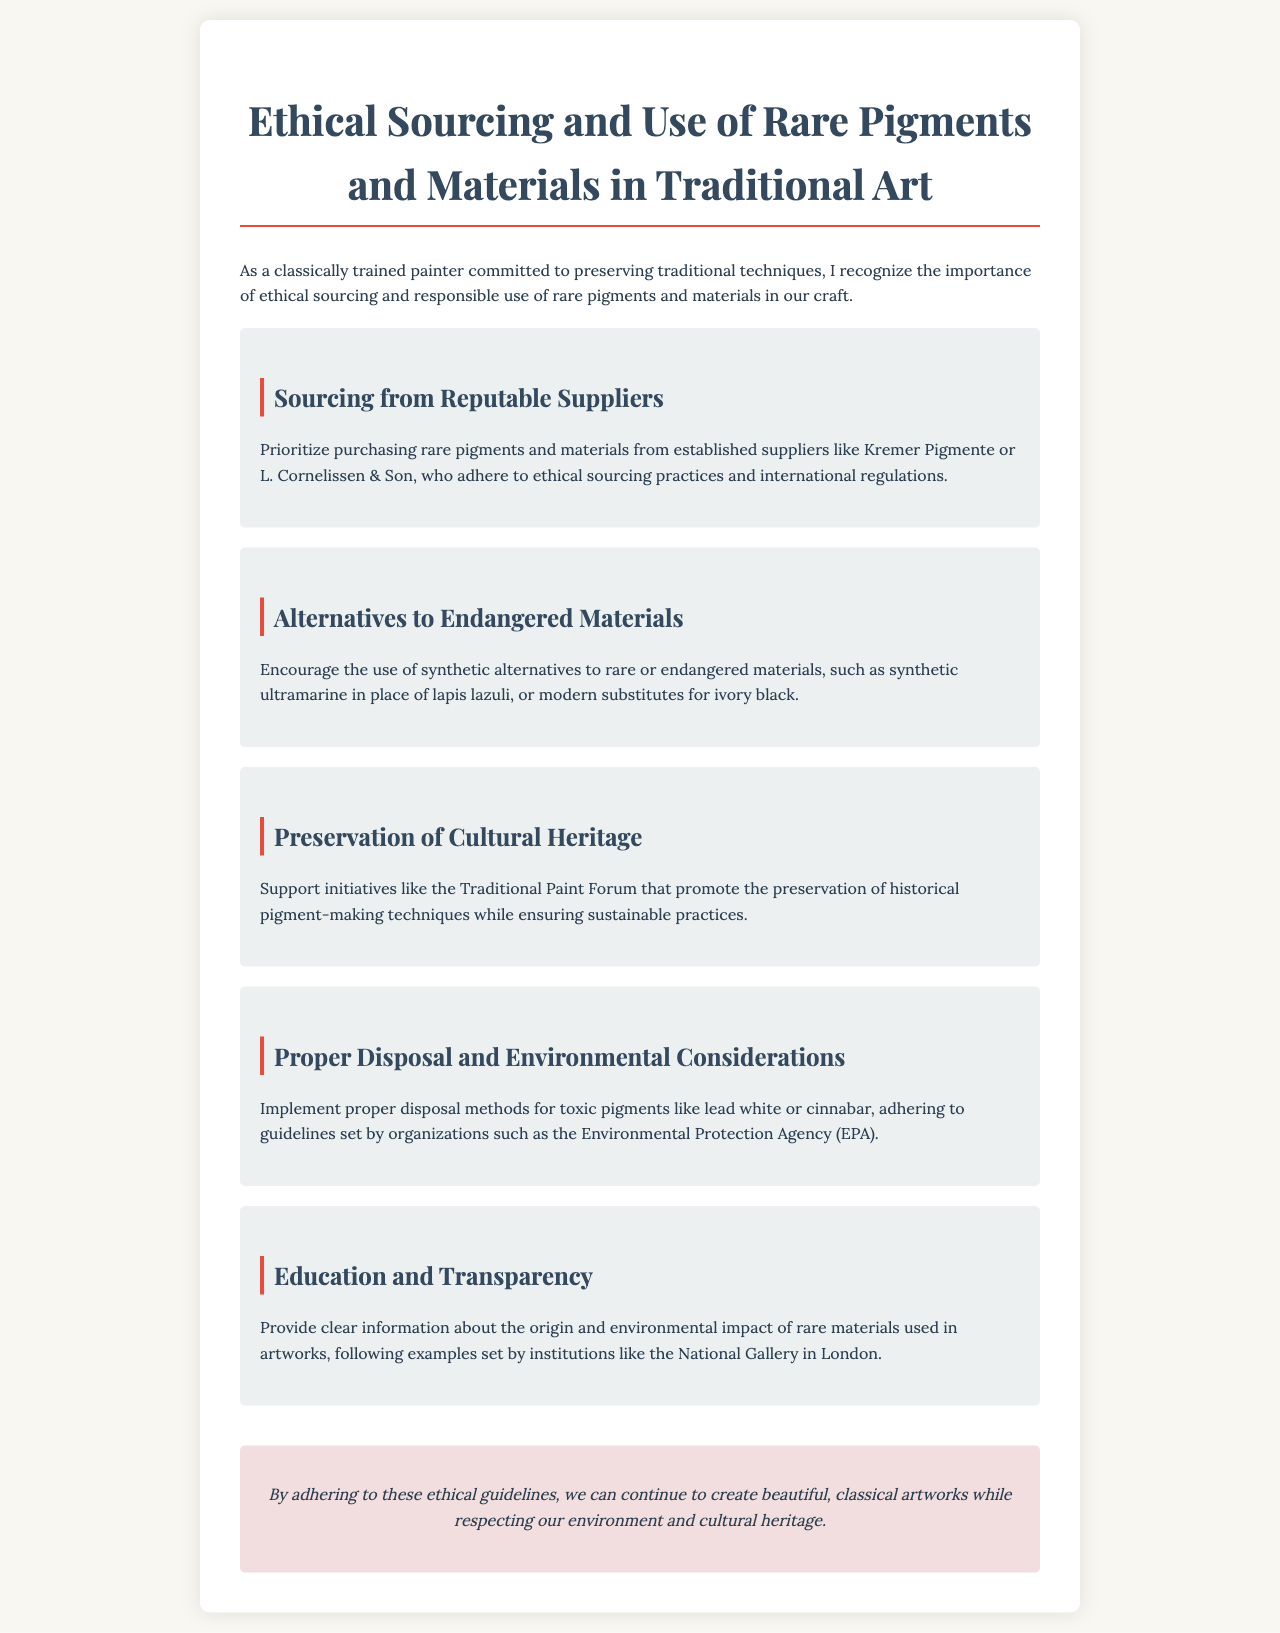What is the title of the document? The title is explicitly stated at the beginning of the document.
Answer: Ethical Sourcing and Use of Rare Pigments and Materials in Traditional Art Who are two established suppliers mentioned? The document lists specific suppliers known for ethical practices.
Answer: Kremer Pigmente, L. Cornelissen & Son What is encouraged as an alternative to endangered materials? The document suggests modern substitutes instead of using rare materials.
Answer: Synthetic alternatives What initiative is mentioned for preserving pigment-making techniques? The document references a specific initiative supporting cultural heritage preservation.
Answer: Traditional Paint Forum What toxic pigment requires proper disposal according to the document? The document mentions a specific toxic pigment that needs careful handling.
Answer: Lead white How does the document suggest providing transparency? The document specifies a method of ensuring transparency regarding materials used.
Answer: Clear information about the origin and environmental impact 